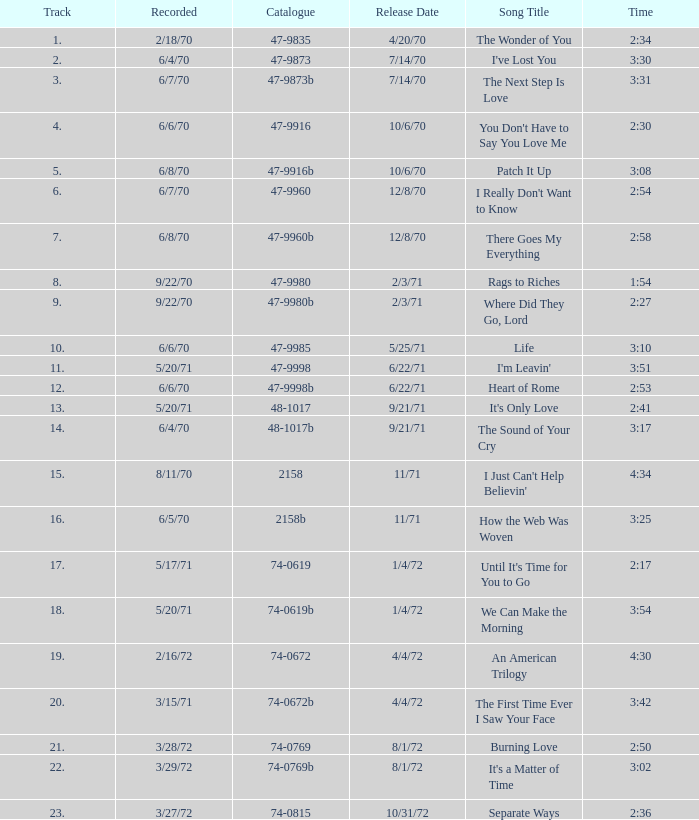Which track was launched 12/8/70 with a duration of 2:54? I Really Don't Want to Know. 